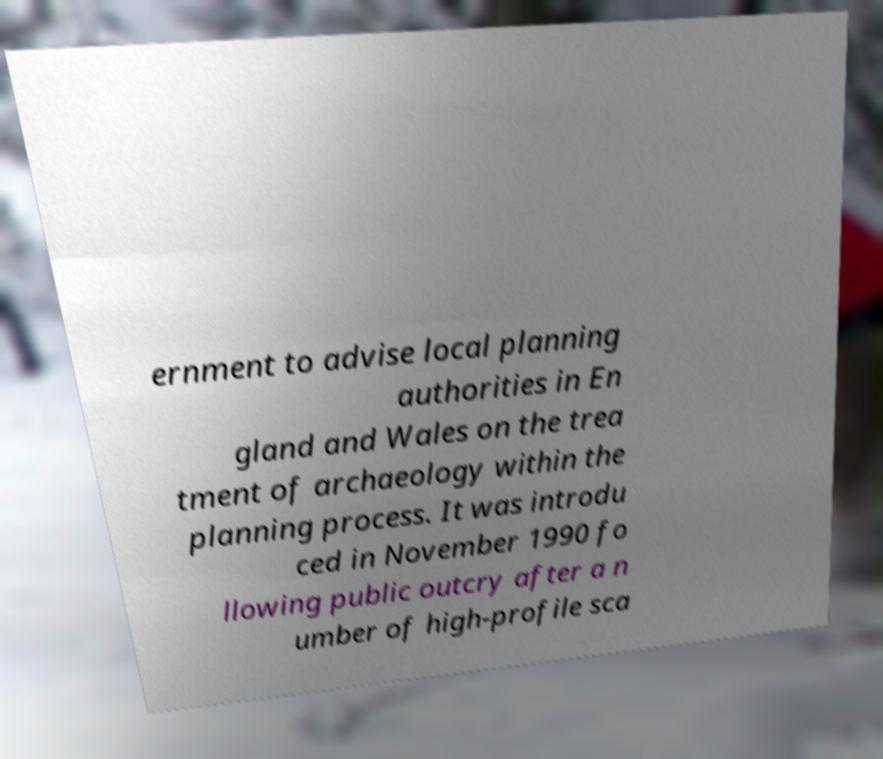Could you extract and type out the text from this image? ernment to advise local planning authorities in En gland and Wales on the trea tment of archaeology within the planning process. It was introdu ced in November 1990 fo llowing public outcry after a n umber of high-profile sca 